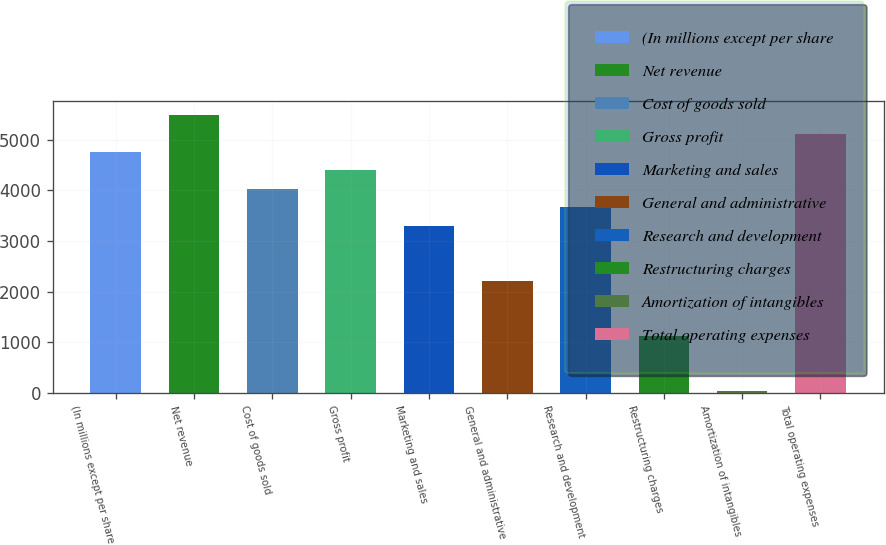<chart> <loc_0><loc_0><loc_500><loc_500><bar_chart><fcel>(In millions except per share<fcel>Net revenue<fcel>Cost of goods sold<fcel>Gross profit<fcel>Marketing and sales<fcel>General and administrative<fcel>Research and development<fcel>Restructuring charges<fcel>Amortization of intangibles<fcel>Total operating expenses<nl><fcel>4754.3<fcel>5480.5<fcel>4028.1<fcel>4391.2<fcel>3301.9<fcel>2212.6<fcel>3665<fcel>1123.3<fcel>34<fcel>5117.4<nl></chart> 